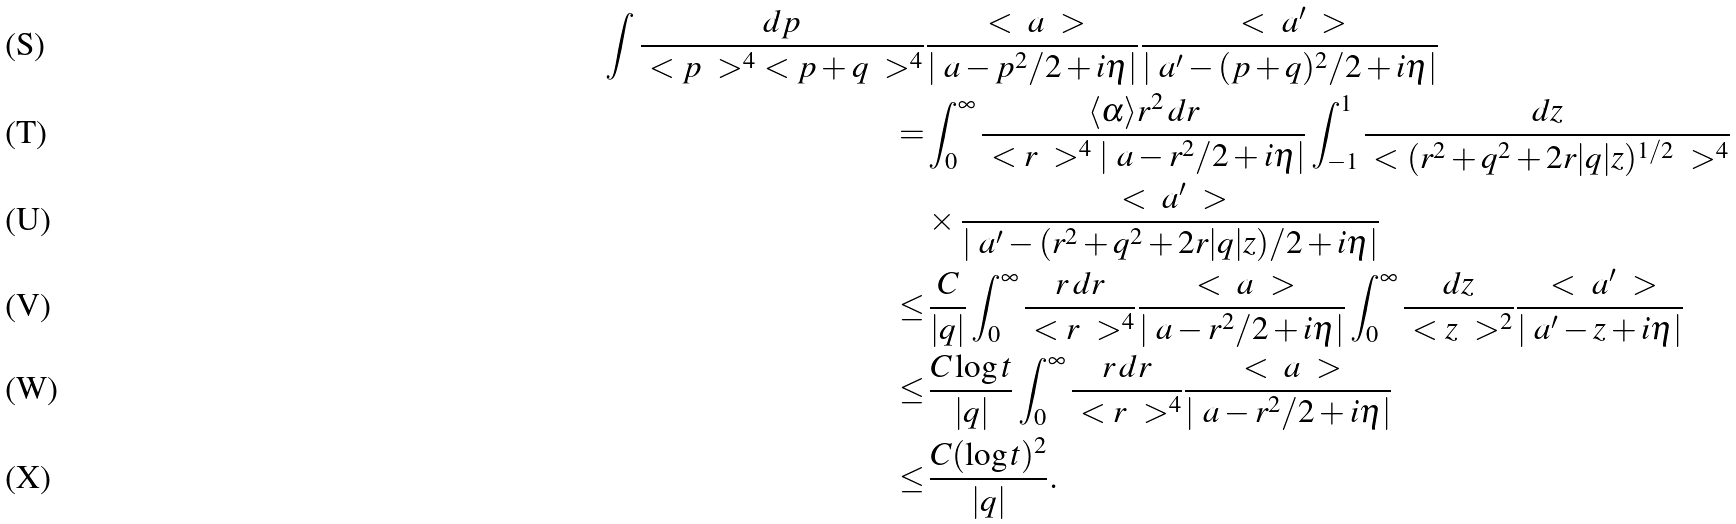<formula> <loc_0><loc_0><loc_500><loc_500>\int \frac { d p } { \ < p \ > ^ { 4 } \ < p + q \ > ^ { 4 } } & \frac { \ < \ a \ > } { | \ a - p ^ { 2 } / 2 + i \eta | } \frac { \ < \ a ^ { \prime } \ > } { | \ a ^ { \prime } - ( p + q ) ^ { 2 } / 2 + i \eta | } \\ = & \int _ { 0 } ^ { \infty } \frac { \langle \alpha \rangle r ^ { 2 } \, d r } { \ < r \ > ^ { 4 } | \ a - r ^ { 2 } / 2 + i \eta | } \int _ { - 1 } ^ { 1 } \frac { d z } { \ < ( r ^ { 2 } + q ^ { 2 } + 2 r | q | z ) ^ { 1 / 2 } \ > ^ { 4 } } \\ & \times \frac { \ < \ a ^ { \prime } \ > } { | \ a ^ { \prime } - ( r ^ { 2 } + q ^ { 2 } + 2 r | q | z ) / 2 + i \eta | } \\ \leq & \, \frac { C } { | q | } \int _ { 0 } ^ { \infty } \frac { r \, d r } { \ < r \ > ^ { 4 } } \frac { \ < \ a \ > } { | \ a - r ^ { 2 } / 2 + i \eta | } \int _ { 0 } ^ { \infty } \frac { d z } { \ < z \ > ^ { 2 } } \frac { \ < \ a ^ { \prime } \ > } { | \ a ^ { \prime } - z + i \eta | } \\ \leq & \, \frac { C \log t } { | q | } \int _ { 0 } ^ { \infty } \frac { r \, d r } { \ < r \ > ^ { 4 } } \frac { \ < \ a \ > } { | \ a - r ^ { 2 } / 2 + i \eta | } \\ \leq & \, \frac { C ( \log t ) ^ { 2 } } { | q | } .</formula> 